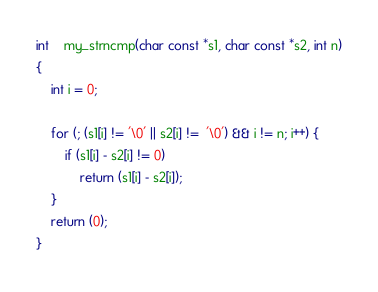Convert code to text. <code><loc_0><loc_0><loc_500><loc_500><_C_>int	my_strncmp(char const *s1, char const *s2, int n)
{
	int i = 0;

	for (; (s1[i] != '\0' || s2[i] !=  '\0') && i != n; i++) {
		if (s1[i] - s2[i] != 0)
			return (s1[i] - s2[i]);
	}
	return (0);
}
</code> 